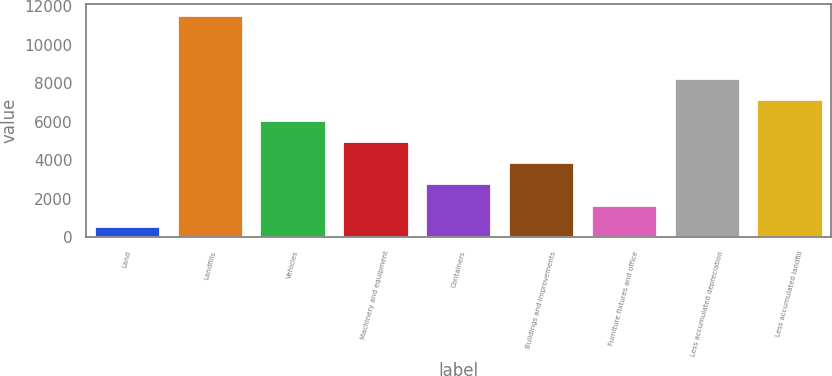<chart> <loc_0><loc_0><loc_500><loc_500><bar_chart><fcel>Land<fcel>Landfills<fcel>Vehicles<fcel>Machinery and equipment<fcel>Containers<fcel>Buildings and improvements<fcel>Furniture fixtures and office<fcel>Less accumulated depreciation<fcel>Less accumulated landfill<nl><fcel>598<fcel>11549<fcel>6073.5<fcel>4978.4<fcel>2788.2<fcel>3883.3<fcel>1693.1<fcel>8263.7<fcel>7168.6<nl></chart> 